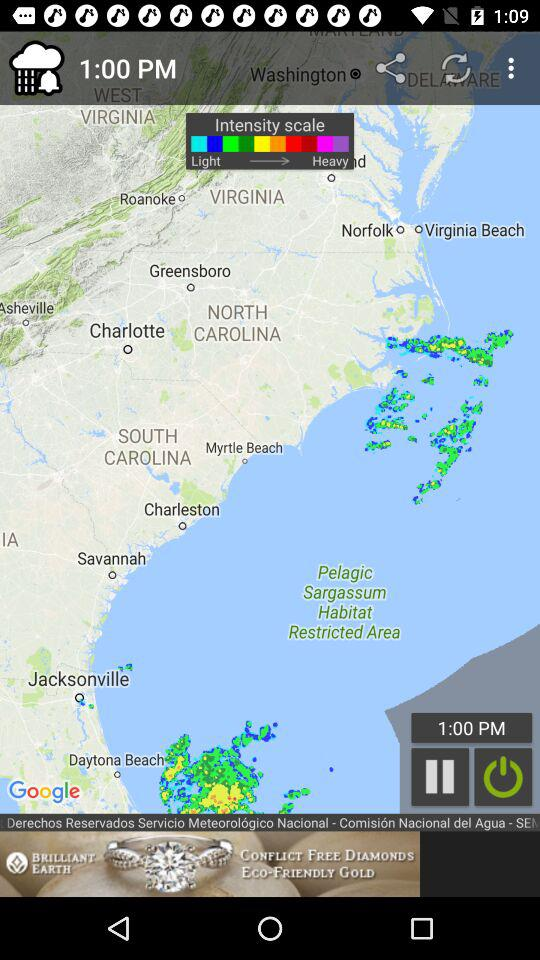Through which applications can this be shared?
When the provided information is insufficient, respond with <no answer>. <no answer> 